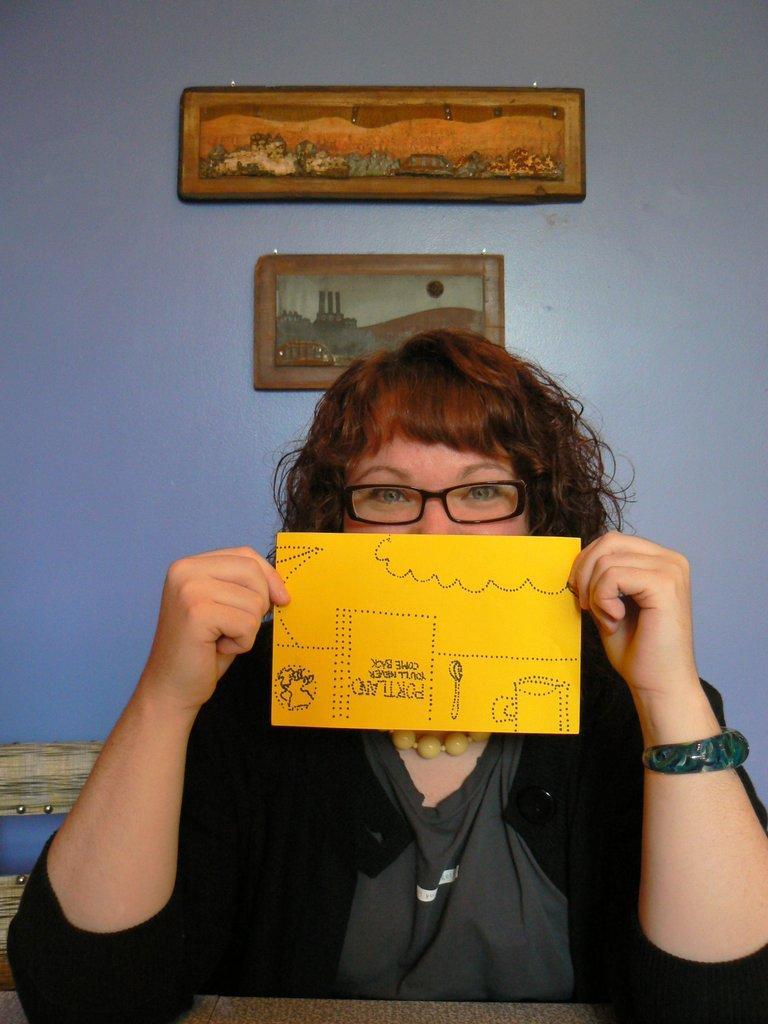Could you give a brief overview of what you see in this image? In this picture there is a woman who is wearing spectacle, jacket, t-shirt, watch and she is holding a yellow paper. She is sitting near to the table. Behind her I can see the frame and painting frame on the wall. 